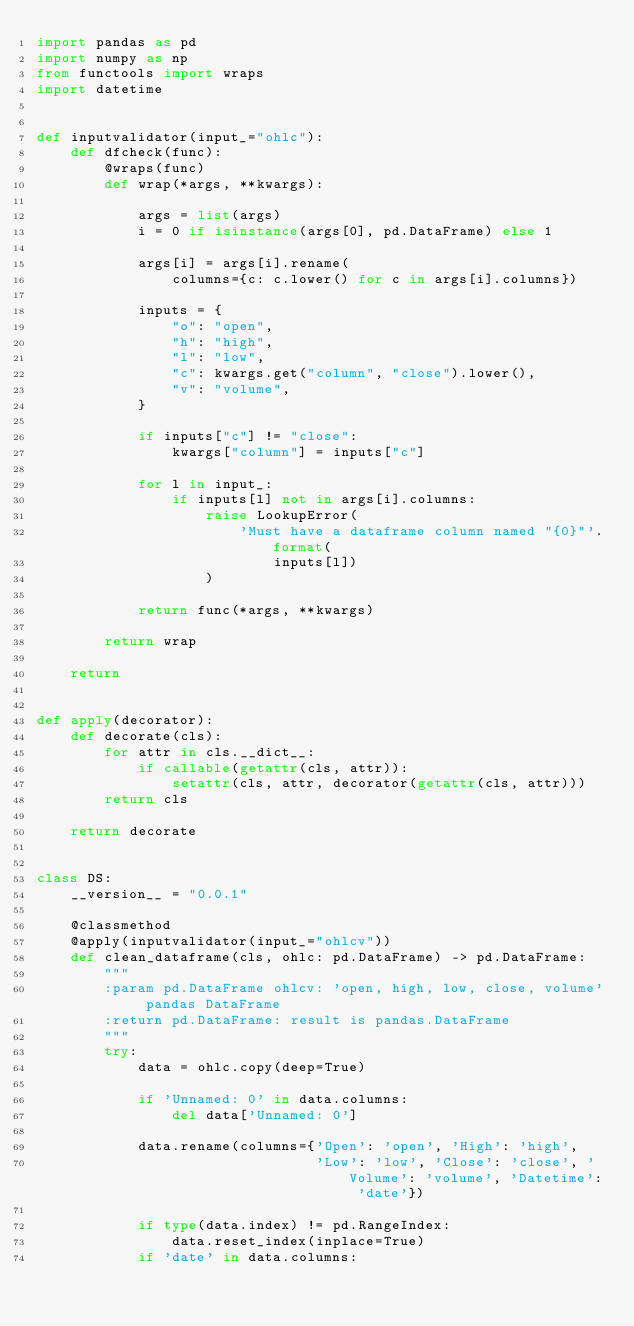Convert code to text. <code><loc_0><loc_0><loc_500><loc_500><_Python_>import pandas as pd
import numpy as np
from functools import wraps
import datetime


def inputvalidator(input_="ohlc"):
    def dfcheck(func):
        @wraps(func)
        def wrap(*args, **kwargs):

            args = list(args)
            i = 0 if isinstance(args[0], pd.DataFrame) else 1

            args[i] = args[i].rename(
                columns={c: c.lower() for c in args[i].columns})

            inputs = {
                "o": "open",
                "h": "high",
                "l": "low",
                "c": kwargs.get("column", "close").lower(),
                "v": "volume",
            }

            if inputs["c"] != "close":
                kwargs["column"] = inputs["c"]

            for l in input_:
                if inputs[l] not in args[i].columns:
                    raise LookupError(
                        'Must have a dataframe column named "{0}"'.format(
                            inputs[l])
                    )

            return func(*args, **kwargs)

        return wrap

    return


def apply(decorator):
    def decorate(cls):
        for attr in cls.__dict__:
            if callable(getattr(cls, attr)):
                setattr(cls, attr, decorator(getattr(cls, attr)))
        return cls

    return decorate


class DS:
    __version__ = "0.0.1"

    @classmethod
    @apply(inputvalidator(input_="ohlcv"))
    def clean_dataframe(cls, ohlc: pd.DataFrame) -> pd.DataFrame:
        """
        :param pd.DataFrame ohlcv: 'open, high, low, close, volume' pandas DataFrame
        :return pd.DataFrame: result is pandas.DataFrame
        """
        try:
            data = ohlc.copy(deep=True)

            if 'Unnamed: 0' in data.columns:
                del data['Unnamed: 0']

            data.rename(columns={'Open': 'open', 'High': 'high',
                                 'Low': 'low', 'Close': 'close', 'Volume': 'volume', 'Datetime': 'date'})

            if type(data.index) != pd.RangeIndex:
                data.reset_index(inplace=True)
            if 'date' in data.columns:</code> 